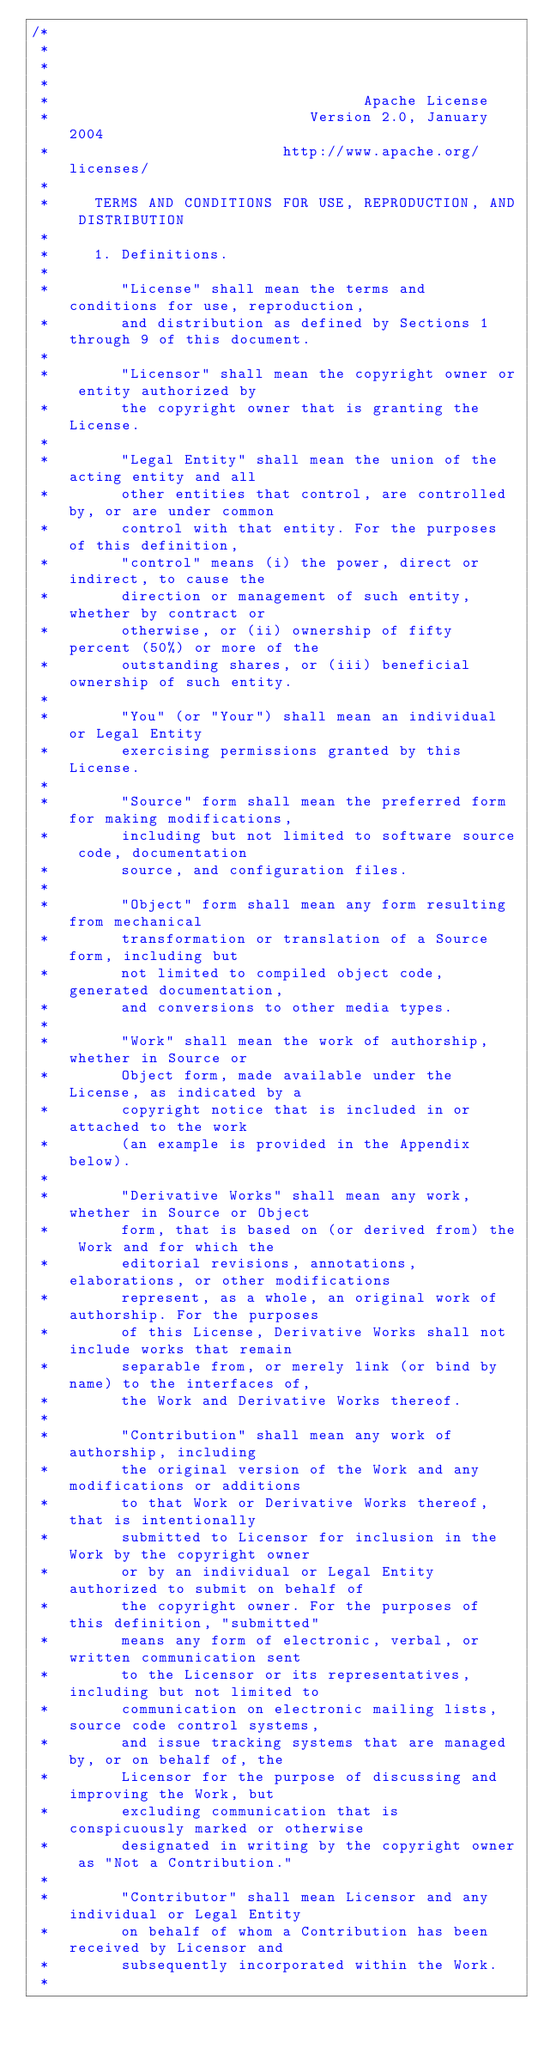Convert code to text. <code><loc_0><loc_0><loc_500><loc_500><_Java_>/*
 *
 *
 *
 *                                   Apache License
 *                             Version 2.0, January 2004
 *                          http://www.apache.org/licenses/
 *
 *     TERMS AND CONDITIONS FOR USE, REPRODUCTION, AND DISTRIBUTION
 *
 *     1. Definitions.
 *
 *        "License" shall mean the terms and conditions for use, reproduction,
 *        and distribution as defined by Sections 1 through 9 of this document.
 *
 *        "Licensor" shall mean the copyright owner or entity authorized by
 *        the copyright owner that is granting the License.
 *
 *        "Legal Entity" shall mean the union of the acting entity and all
 *        other entities that control, are controlled by, or are under common
 *        control with that entity. For the purposes of this definition,
 *        "control" means (i) the power, direct or indirect, to cause the
 *        direction or management of such entity, whether by contract or
 *        otherwise, or (ii) ownership of fifty percent (50%) or more of the
 *        outstanding shares, or (iii) beneficial ownership of such entity.
 *
 *        "You" (or "Your") shall mean an individual or Legal Entity
 *        exercising permissions granted by this License.
 *
 *        "Source" form shall mean the preferred form for making modifications,
 *        including but not limited to software source code, documentation
 *        source, and configuration files.
 *
 *        "Object" form shall mean any form resulting from mechanical
 *        transformation or translation of a Source form, including but
 *        not limited to compiled object code, generated documentation,
 *        and conversions to other media types.
 *
 *        "Work" shall mean the work of authorship, whether in Source or
 *        Object form, made available under the License, as indicated by a
 *        copyright notice that is included in or attached to the work
 *        (an example is provided in the Appendix below).
 *
 *        "Derivative Works" shall mean any work, whether in Source or Object
 *        form, that is based on (or derived from) the Work and for which the
 *        editorial revisions, annotations, elaborations, or other modifications
 *        represent, as a whole, an original work of authorship. For the purposes
 *        of this License, Derivative Works shall not include works that remain
 *        separable from, or merely link (or bind by name) to the interfaces of,
 *        the Work and Derivative Works thereof.
 *
 *        "Contribution" shall mean any work of authorship, including
 *        the original version of the Work and any modifications or additions
 *        to that Work or Derivative Works thereof, that is intentionally
 *        submitted to Licensor for inclusion in the Work by the copyright owner
 *        or by an individual or Legal Entity authorized to submit on behalf of
 *        the copyright owner. For the purposes of this definition, "submitted"
 *        means any form of electronic, verbal, or written communication sent
 *        to the Licensor or its representatives, including but not limited to
 *        communication on electronic mailing lists, source code control systems,
 *        and issue tracking systems that are managed by, or on behalf of, the
 *        Licensor for the purpose of discussing and improving the Work, but
 *        excluding communication that is conspicuously marked or otherwise
 *        designated in writing by the copyright owner as "Not a Contribution."
 *
 *        "Contributor" shall mean Licensor and any individual or Legal Entity
 *        on behalf of whom a Contribution has been received by Licensor and
 *        subsequently incorporated within the Work.
 *</code> 